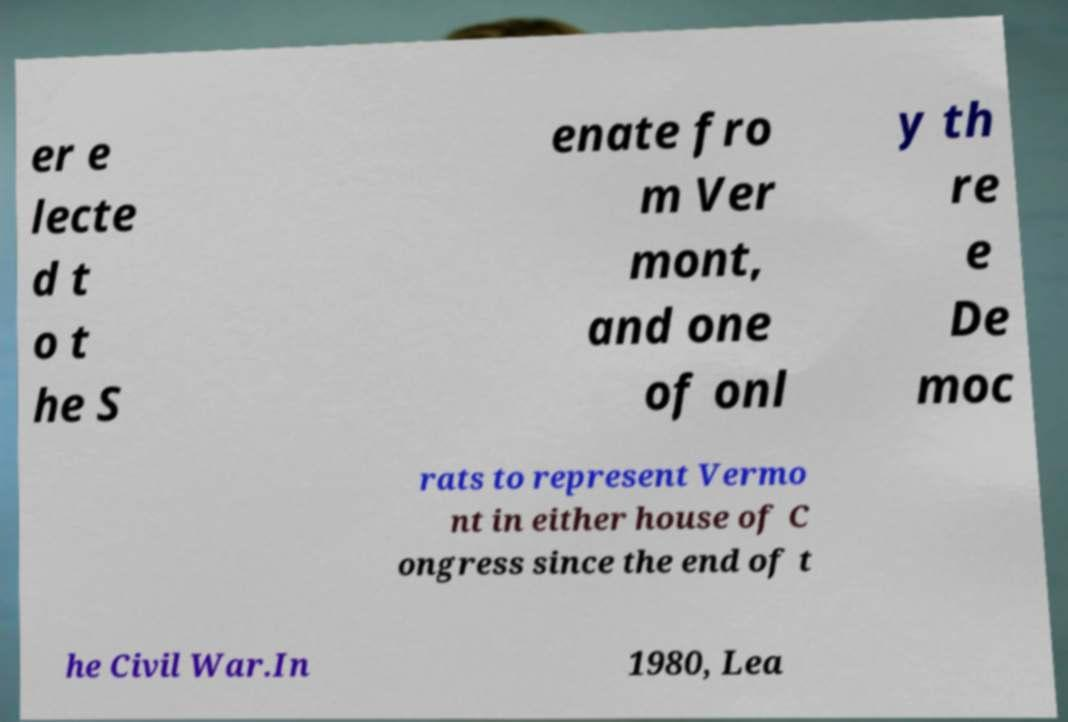Please identify and transcribe the text found in this image. er e lecte d t o t he S enate fro m Ver mont, and one of onl y th re e De moc rats to represent Vermo nt in either house of C ongress since the end of t he Civil War.In 1980, Lea 